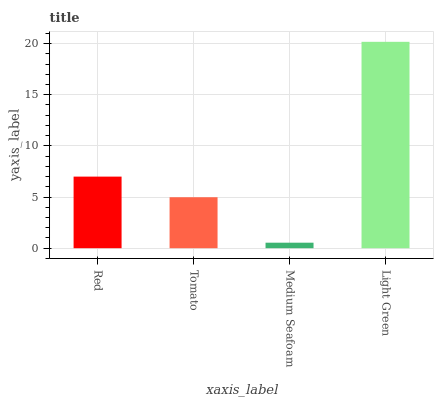Is Medium Seafoam the minimum?
Answer yes or no. Yes. Is Light Green the maximum?
Answer yes or no. Yes. Is Tomato the minimum?
Answer yes or no. No. Is Tomato the maximum?
Answer yes or no. No. Is Red greater than Tomato?
Answer yes or no. Yes. Is Tomato less than Red?
Answer yes or no. Yes. Is Tomato greater than Red?
Answer yes or no. No. Is Red less than Tomato?
Answer yes or no. No. Is Red the high median?
Answer yes or no. Yes. Is Tomato the low median?
Answer yes or no. Yes. Is Tomato the high median?
Answer yes or no. No. Is Red the low median?
Answer yes or no. No. 